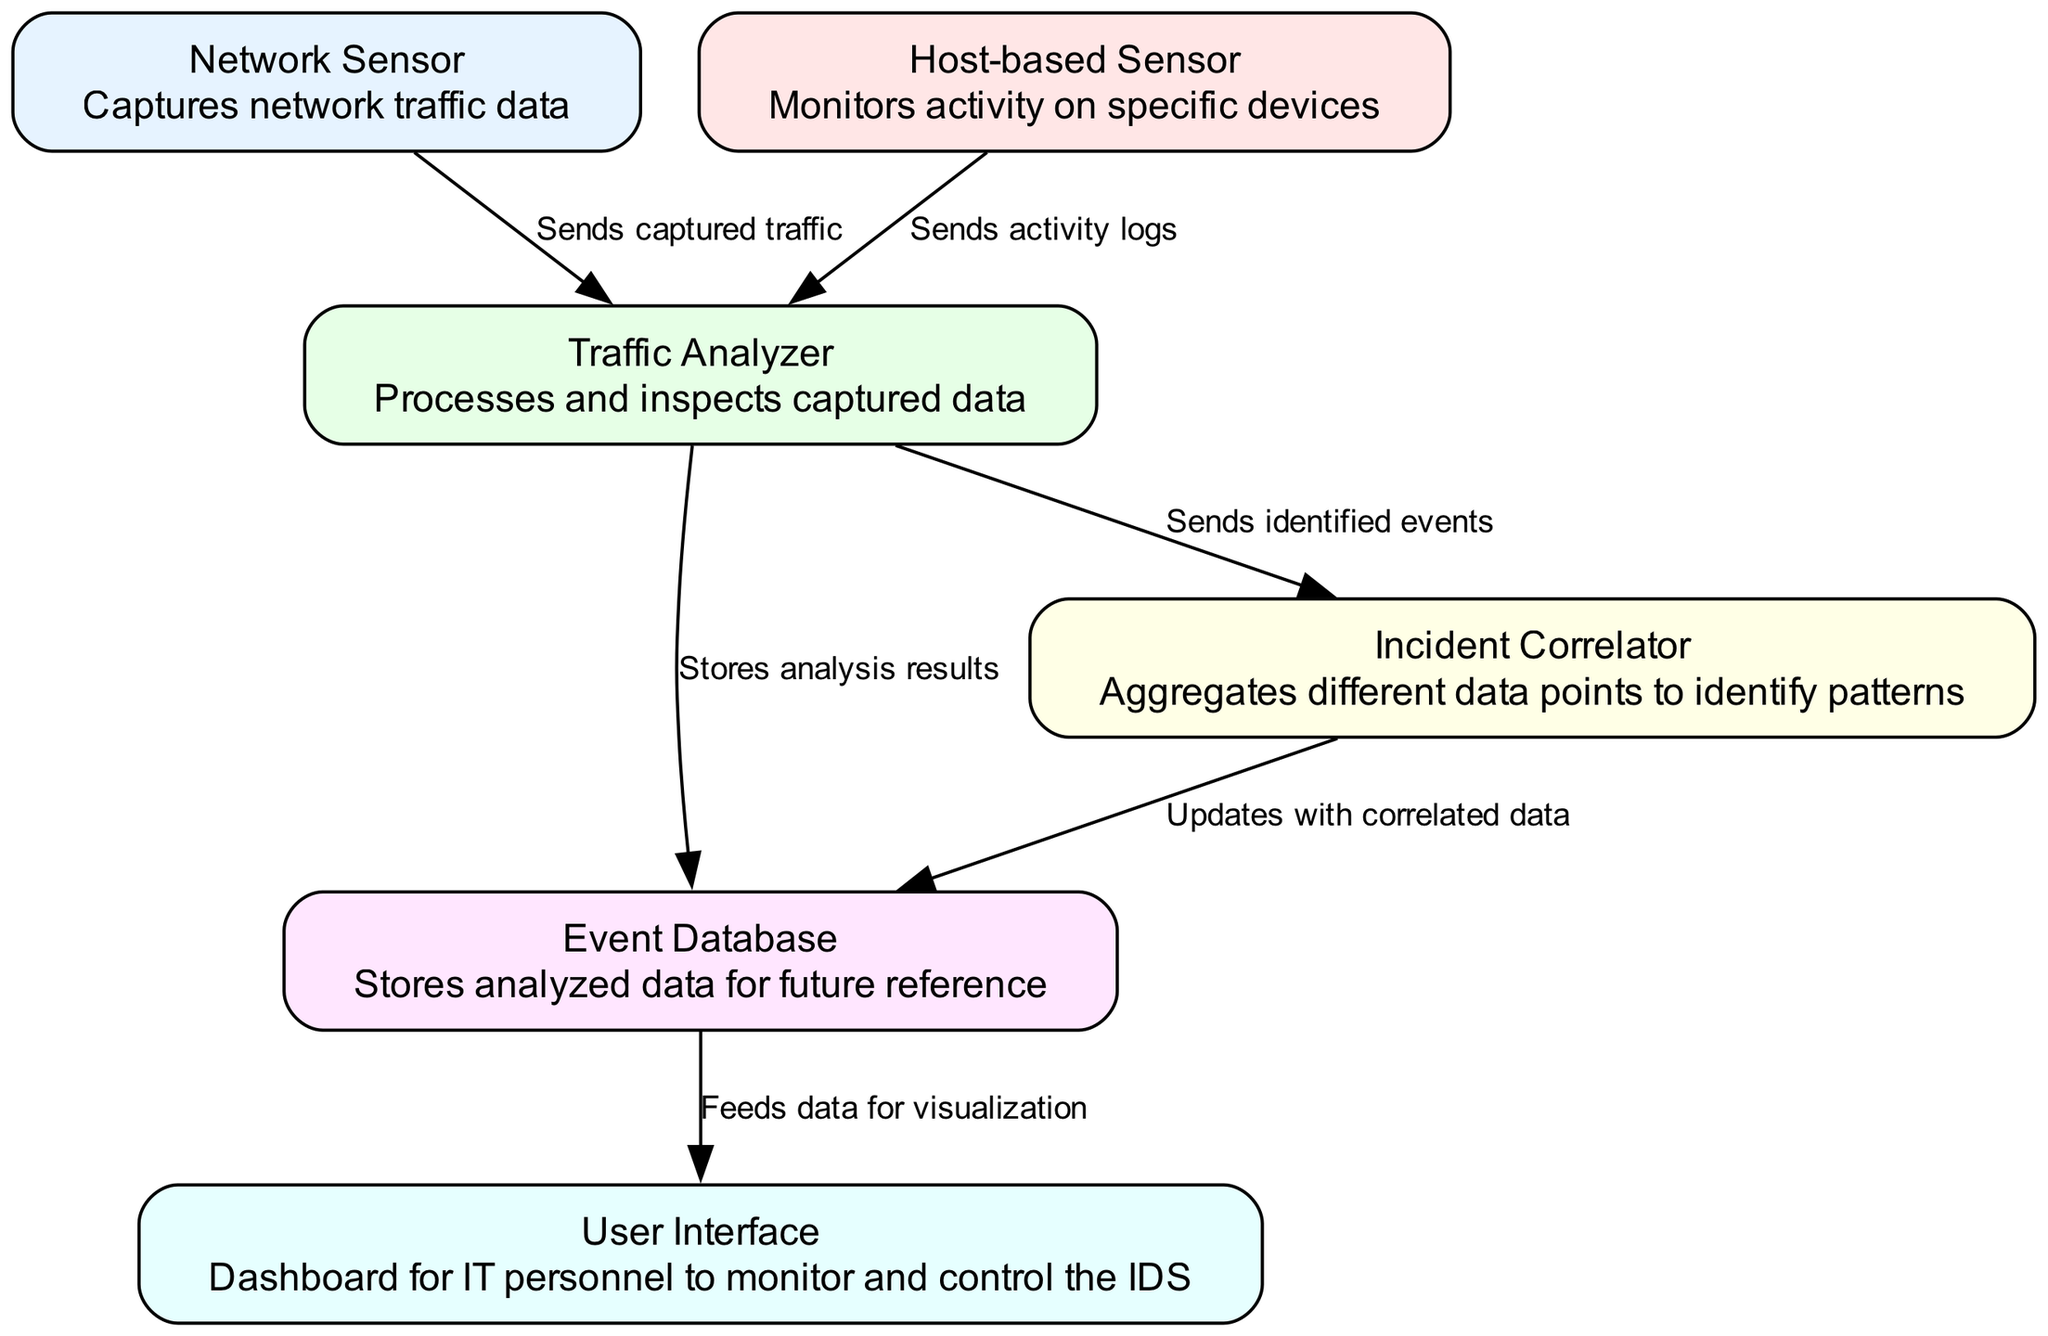What is the label of the first node? The first node in the diagram is labeled 'Network Sensor', which is indicated in the node list.
Answer: Network Sensor How many sensors are present in the diagram? There are two sensors in the diagram: 'Network Sensor' and 'Host-based Sensor', as identified in the nodes list.
Answer: 2 What does the 'Traffic Analyzer' node do? The 'Traffic Analyzer' node is described as 'Processes and inspects captured data', providing information regarding its function.
Answer: Processes and inspects captured data Which node sends identified events to the correlator? The 'Traffic Analyzer' node sends identified events to the 'Incident Correlator', as shown by the edge connecting these two nodes.
Answer: Traffic Analyzer What updates the Event Database with correlated data? The 'Incident Correlator' updates the 'Event Database' with correlated data, as indicated by the edge between these nodes.
Answer: Incident Correlator How many edges are there in the diagram? There are six edges connecting the nodes, as listed in the edges section of the diagram's data.
Answer: 6 What is the role of the 'User Interface' in this architecture? The 'User Interface' is described as 'Dashboard for IT personnel to monitor and control the IDS', indicating its purpose in the architecture.
Answer: Dashboard for IT personnel to monitor and control the IDS Which node is responsible for storing analyzed data? The 'Event Database' is responsible for storing analyzed data, based on the edge that shows storage of analysis results from the Traffic Analyzer.
Answer: Event Database What type of data does the 'Network Sensor' capture? The 'Network Sensor' captures 'network traffic data', as explicitly stated in its description.
Answer: Network traffic data 